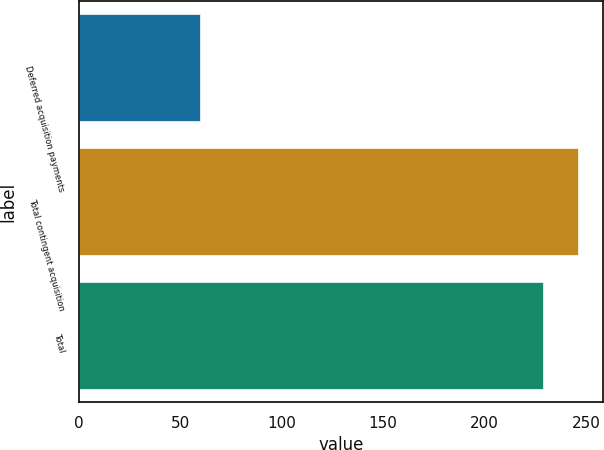Convert chart to OTSL. <chart><loc_0><loc_0><loc_500><loc_500><bar_chart><fcel>Deferred acquisition payments<fcel>Total contingent acquisition<fcel>Total<nl><fcel>60<fcel>246.14<fcel>228.9<nl></chart> 